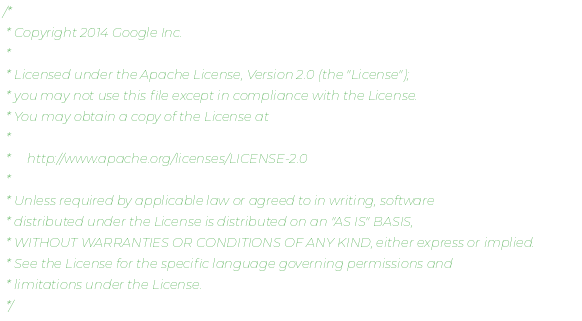<code> <loc_0><loc_0><loc_500><loc_500><_Kotlin_>/*
 * Copyright 2014 Google Inc.
 *
 * Licensed under the Apache License, Version 2.0 (the "License");
 * you may not use this file except in compliance with the License.
 * You may obtain a copy of the License at
 *
 *     http://www.apache.org/licenses/LICENSE-2.0
 *
 * Unless required by applicable law or agreed to in writing, software
 * distributed under the License is distributed on an "AS IS" BASIS,
 * WITHOUT WARRANTIES OR CONDITIONS OF ANY KIND, either express or implied.
 * See the License for the specific language governing permissions and
 * limitations under the License.
 */
</code> 